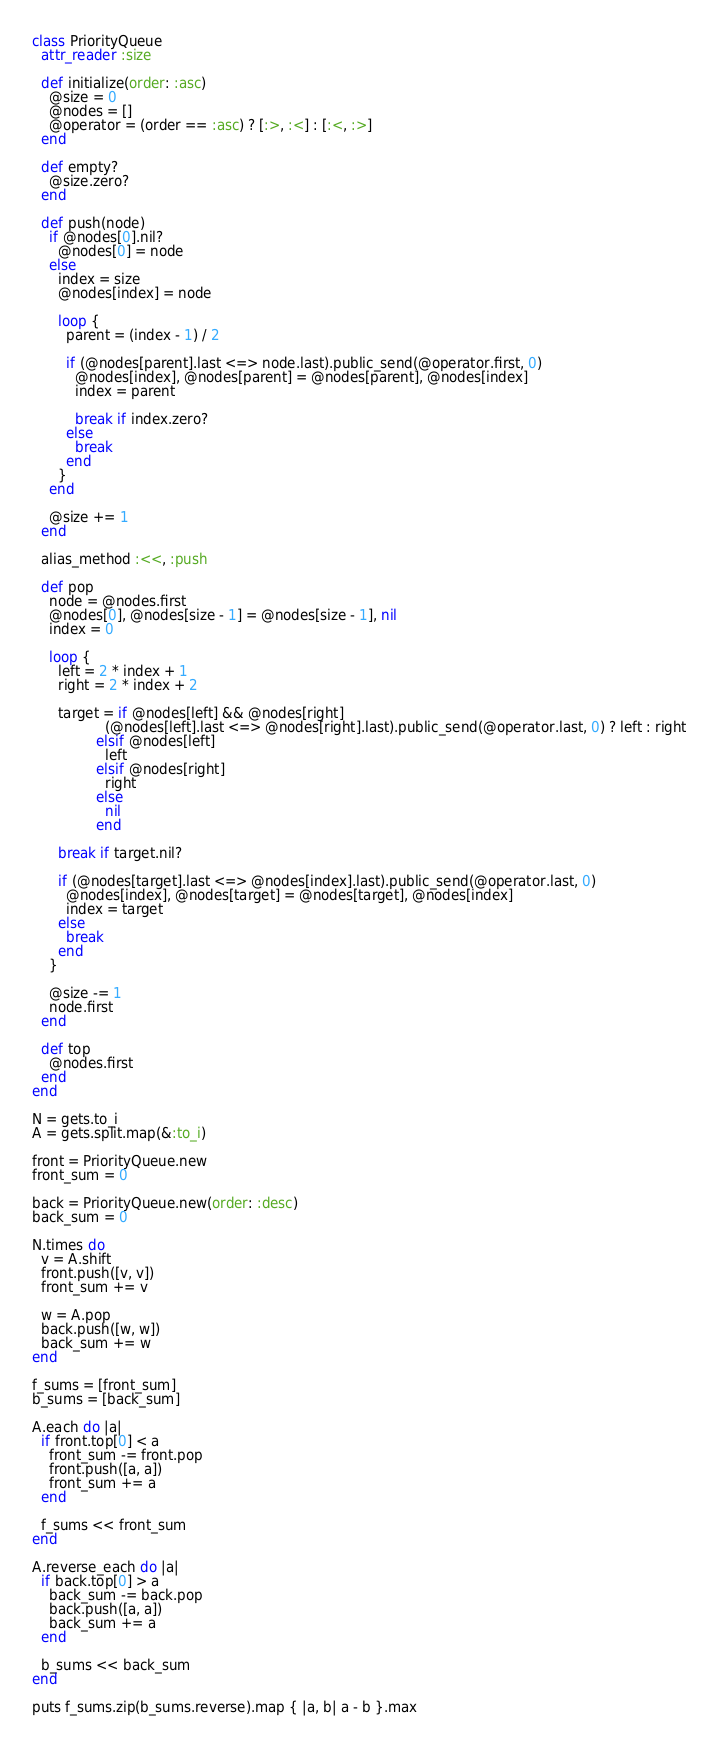Convert code to text. <code><loc_0><loc_0><loc_500><loc_500><_Ruby_>class PriorityQueue
  attr_reader :size

  def initialize(order: :asc)
    @size = 0
    @nodes = []
    @operator = (order == :asc) ? [:>, :<] : [:<, :>]
  end

  def empty?
    @size.zero?
  end

  def push(node)
    if @nodes[0].nil?
      @nodes[0] = node
    else
      index = size
      @nodes[index] = node

      loop {
        parent = (index - 1) / 2

        if (@nodes[parent].last <=> node.last).public_send(@operator.first, 0)
          @nodes[index], @nodes[parent] = @nodes[parent], @nodes[index]
          index = parent

          break if index.zero?
        else
          break
        end
      }
    end

    @size += 1
  end

  alias_method :<<, :push

  def pop
    node = @nodes.first
    @nodes[0], @nodes[size - 1] = @nodes[size - 1], nil
    index = 0

    loop {
      left = 2 * index + 1
      right = 2 * index + 2

      target = if @nodes[left] && @nodes[right]
                 (@nodes[left].last <=> @nodes[right].last).public_send(@operator.last, 0) ? left : right
               elsif @nodes[left]
                 left
               elsif @nodes[right]
                 right
               else
                 nil
               end

      break if target.nil?

      if (@nodes[target].last <=> @nodes[index].last).public_send(@operator.last, 0)
        @nodes[index], @nodes[target] = @nodes[target], @nodes[index]
        index = target
      else
        break
      end
    }

    @size -= 1
    node.first
  end

  def top
    @nodes.first
  end
end

N = gets.to_i
A = gets.split.map(&:to_i)

front = PriorityQueue.new
front_sum = 0

back = PriorityQueue.new(order: :desc)
back_sum = 0

N.times do
  v = A.shift
  front.push([v, v])
  front_sum += v

  w = A.pop
  back.push([w, w])
  back_sum += w
end

f_sums = [front_sum]
b_sums = [back_sum]

A.each do |a|
  if front.top[0] < a
    front_sum -= front.pop
    front.push([a, a])
    front_sum += a
  end

  f_sums << front_sum
end

A.reverse_each do |a|
  if back.top[0] > a
    back_sum -= back.pop
    back.push([a, a])
    back_sum += a
  end

  b_sums << back_sum
end

puts f_sums.zip(b_sums.reverse).map { |a, b| a - b }.max

</code> 